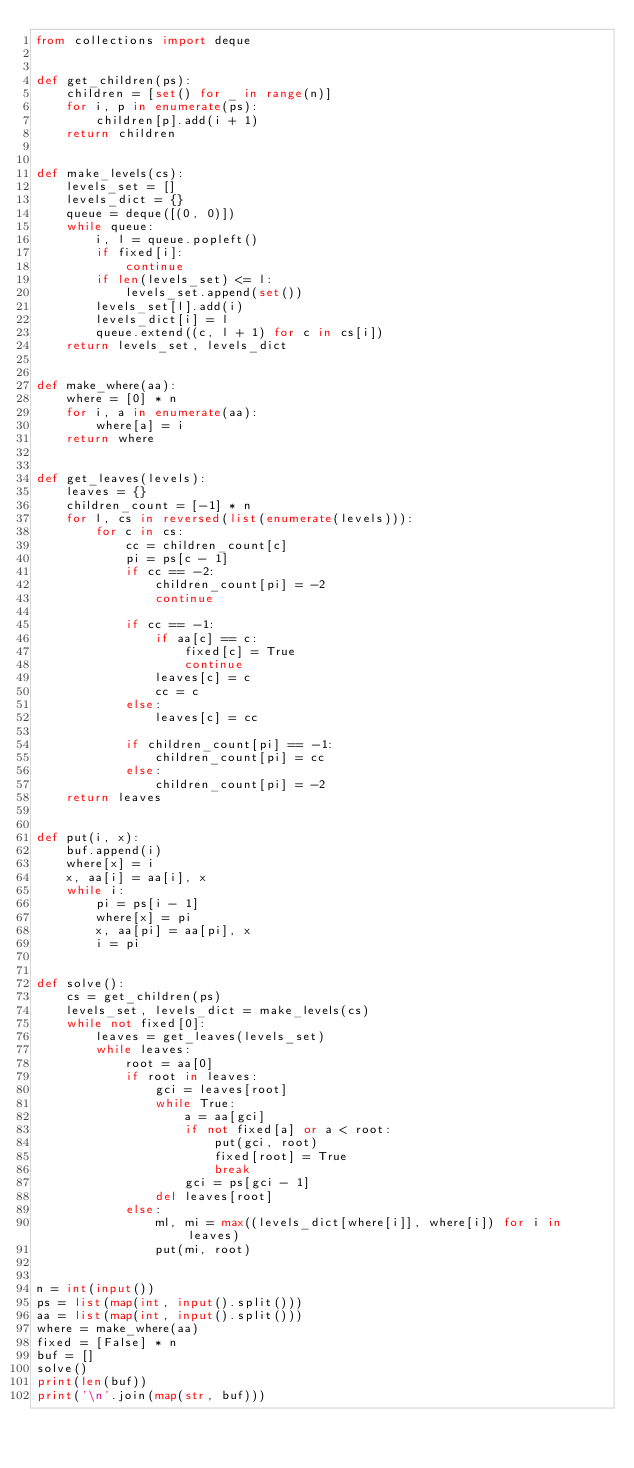<code> <loc_0><loc_0><loc_500><loc_500><_Python_>from collections import deque


def get_children(ps):
    children = [set() for _ in range(n)]
    for i, p in enumerate(ps):
        children[p].add(i + 1)
    return children


def make_levels(cs):
    levels_set = []
    levels_dict = {}
    queue = deque([(0, 0)])
    while queue:
        i, l = queue.popleft()
        if fixed[i]:
            continue
        if len(levels_set) <= l:
            levels_set.append(set())
        levels_set[l].add(i)
        levels_dict[i] = l
        queue.extend((c, l + 1) for c in cs[i])
    return levels_set, levels_dict


def make_where(aa):
    where = [0] * n
    for i, a in enumerate(aa):
        where[a] = i
    return where


def get_leaves(levels):
    leaves = {}
    children_count = [-1] * n
    for l, cs in reversed(list(enumerate(levels))):
        for c in cs:
            cc = children_count[c]
            pi = ps[c - 1]
            if cc == -2:
                children_count[pi] = -2
                continue

            if cc == -1:
                if aa[c] == c:
                    fixed[c] = True
                    continue
                leaves[c] = c
                cc = c
            else:
                leaves[c] = cc

            if children_count[pi] == -1:
                children_count[pi] = cc
            else:
                children_count[pi] = -2
    return leaves


def put(i, x):
    buf.append(i)
    where[x] = i
    x, aa[i] = aa[i], x
    while i:
        pi = ps[i - 1]
        where[x] = pi
        x, aa[pi] = aa[pi], x
        i = pi


def solve():
    cs = get_children(ps)
    levels_set, levels_dict = make_levels(cs)
    while not fixed[0]:
        leaves = get_leaves(levels_set)
        while leaves:
            root = aa[0]
            if root in leaves:
                gci = leaves[root]
                while True:
                    a = aa[gci]
                    if not fixed[a] or a < root:
                        put(gci, root)
                        fixed[root] = True
                        break
                    gci = ps[gci - 1]
                del leaves[root]
            else:
                ml, mi = max((levels_dict[where[i]], where[i]) for i in leaves)
                put(mi, root)


n = int(input())
ps = list(map(int, input().split()))
aa = list(map(int, input().split()))
where = make_where(aa)
fixed = [False] * n
buf = []
solve()
print(len(buf))
print('\n'.join(map(str, buf)))
</code> 